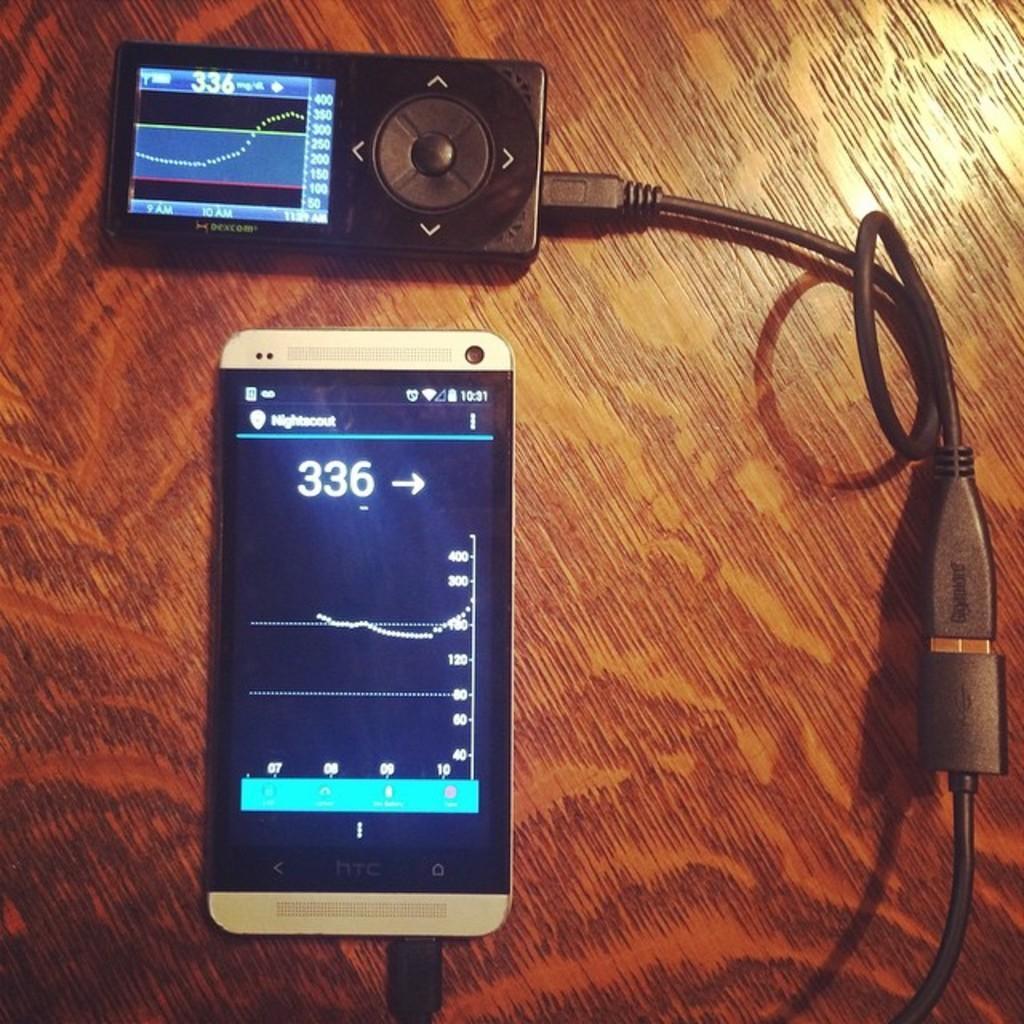Can you describe this image briefly? In this image there is a mobile phone, there is a wire truncated, there is an object on the surface. 